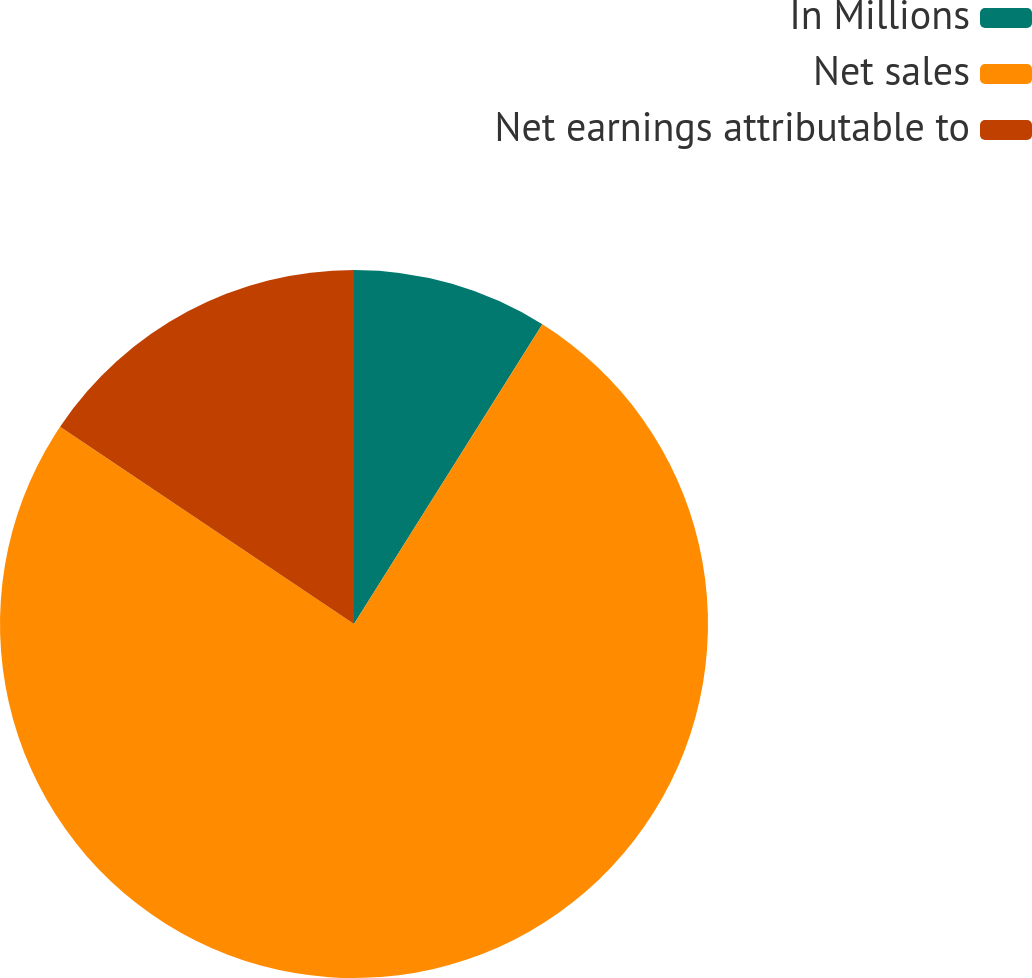Convert chart. <chart><loc_0><loc_0><loc_500><loc_500><pie_chart><fcel>In Millions<fcel>Net sales<fcel>Net earnings attributable to<nl><fcel>8.93%<fcel>75.48%<fcel>15.59%<nl></chart> 